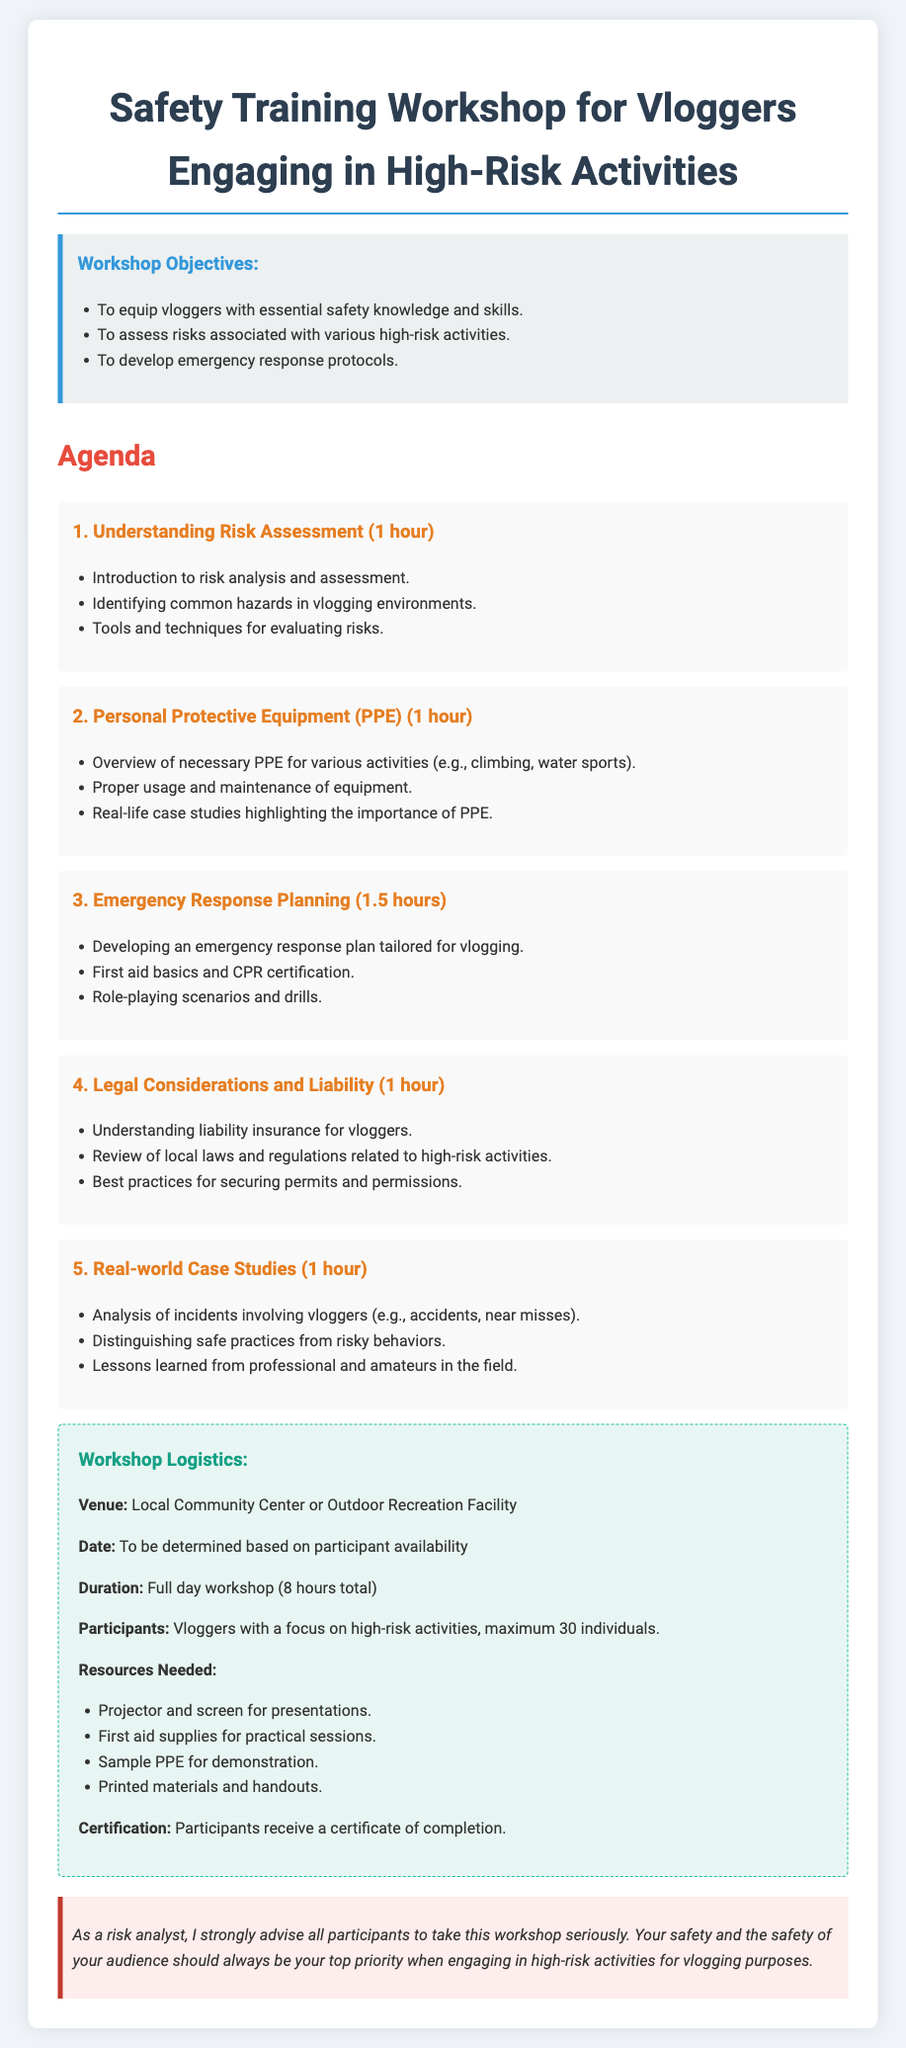What is the duration of the workshop? The duration of the workshop is specified in the logistics section of the document, which states it is a full day workshop totaling eight hours.
Answer: 8 hours How many participants are allowed? The document states the maximum number of individuals that can participate in the workshop, which is thirty.
Answer: 30 individuals What is the first session topic? The document outlines the agenda and indicates that the first session topic is understanding risk assessment.
Answer: Understanding Risk Assessment What is one of the objectives of the workshop? The objectives section of the document lists key goals of the workshop, including equipping vloggers with essential safety knowledge and skills.
Answer: To equip vloggers with essential safety knowledge and skills What type of certification will participants receive? The logistics section mentions the type of certification that participants will receive after completing the workshop, which is a certificate of completion.
Answer: Certificate of completion What is one resource needed for the workshop? The logistics section lists necessary resources, including a projector and screen for presentations as one of the resources needed.
Answer: Projector and screen How long is the emergency response planning session? The document specifies the duration of each session in the agenda, noting that the emergency response planning session lasts one and a half hours.
Answer: 1.5 hours What venue is proposed for the workshop? The logistics section includes a proposed venue for the workshop, which is the local community center or outdoor recreation facility.
Answer: Local Community Center or Outdoor Recreation Facility 